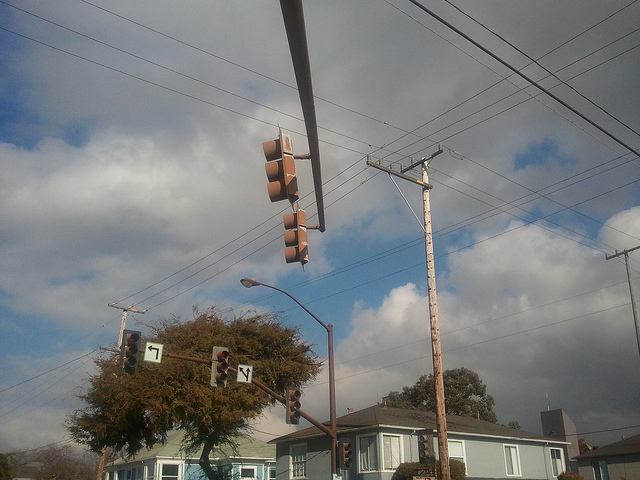<image>What is missing on the tree? It is ambiguous what is missing on the tree. It could be a swing, birds, fruit, or leaves. What is missing on the tree? I don't know what is missing on the tree. There can be swing, birds, fruit, or leaves missing. 